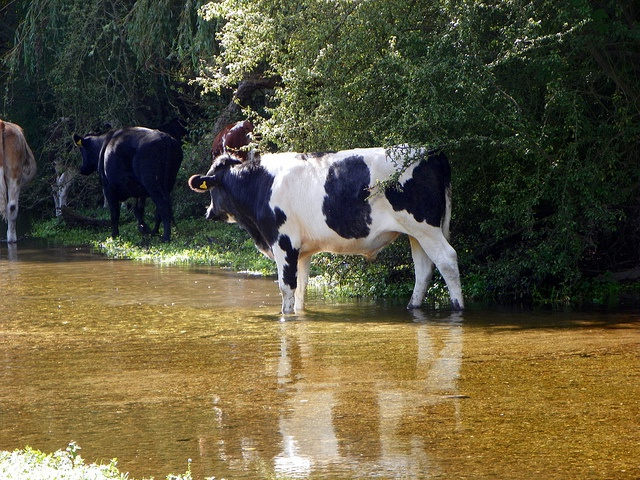Describe the objects in this image and their specific colors. I can see cow in black, lightgray, darkgray, and gray tones, cow in black, gray, and darkgray tones, cow in black and gray tones, and cow in black, maroon, brown, and lightgray tones in this image. 